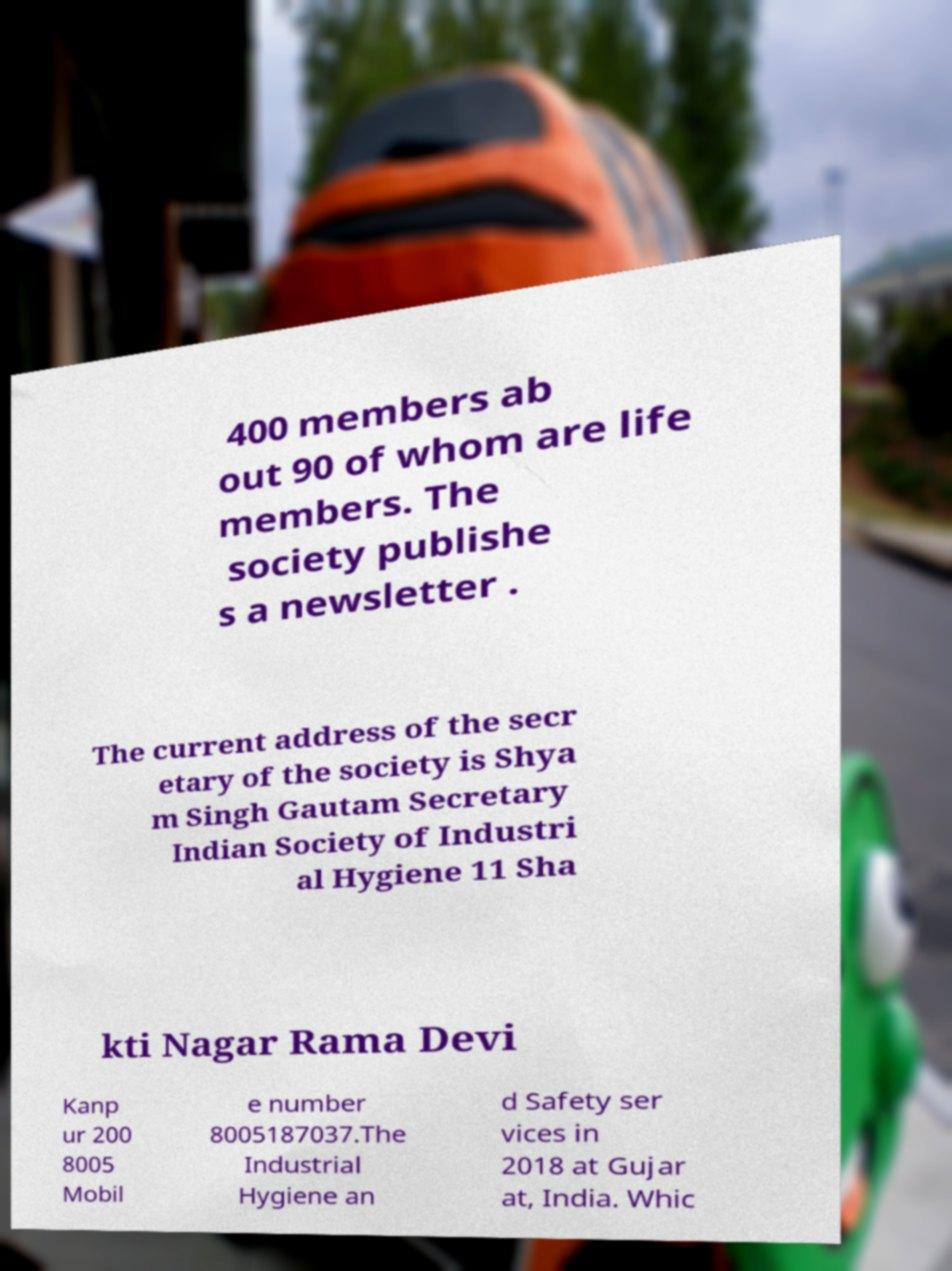Please identify and transcribe the text found in this image. 400 members ab out 90 of whom are life members. The society publishe s a newsletter . The current address of the secr etary of the society is Shya m Singh Gautam Secretary Indian Society of Industri al Hygiene 11 Sha kti Nagar Rama Devi Kanp ur 200 8005 Mobil e number 8005187037.The Industrial Hygiene an d Safety ser vices in 2018 at Gujar at, India. Whic 